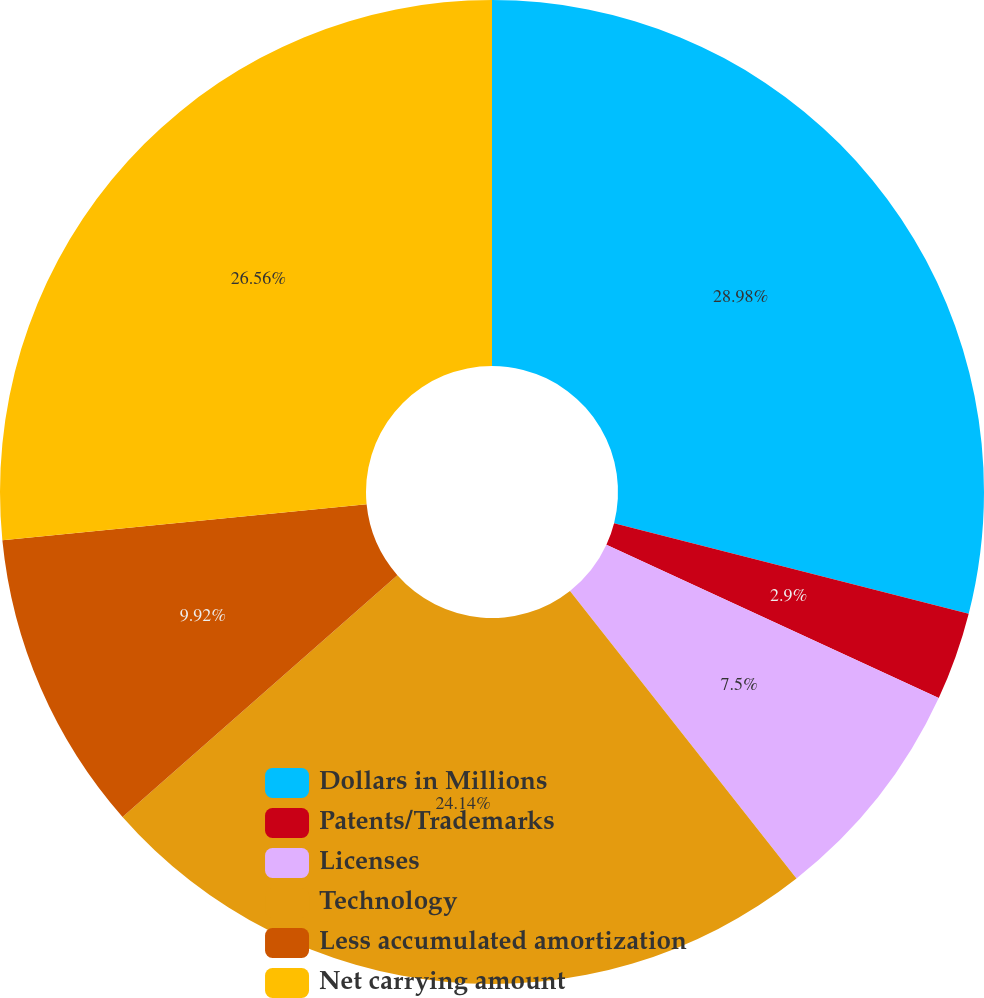Convert chart to OTSL. <chart><loc_0><loc_0><loc_500><loc_500><pie_chart><fcel>Dollars in Millions<fcel>Patents/Trademarks<fcel>Licenses<fcel>Technology<fcel>Less accumulated amortization<fcel>Net carrying amount<nl><fcel>28.98%<fcel>2.9%<fcel>7.5%<fcel>24.14%<fcel>9.92%<fcel>26.56%<nl></chart> 